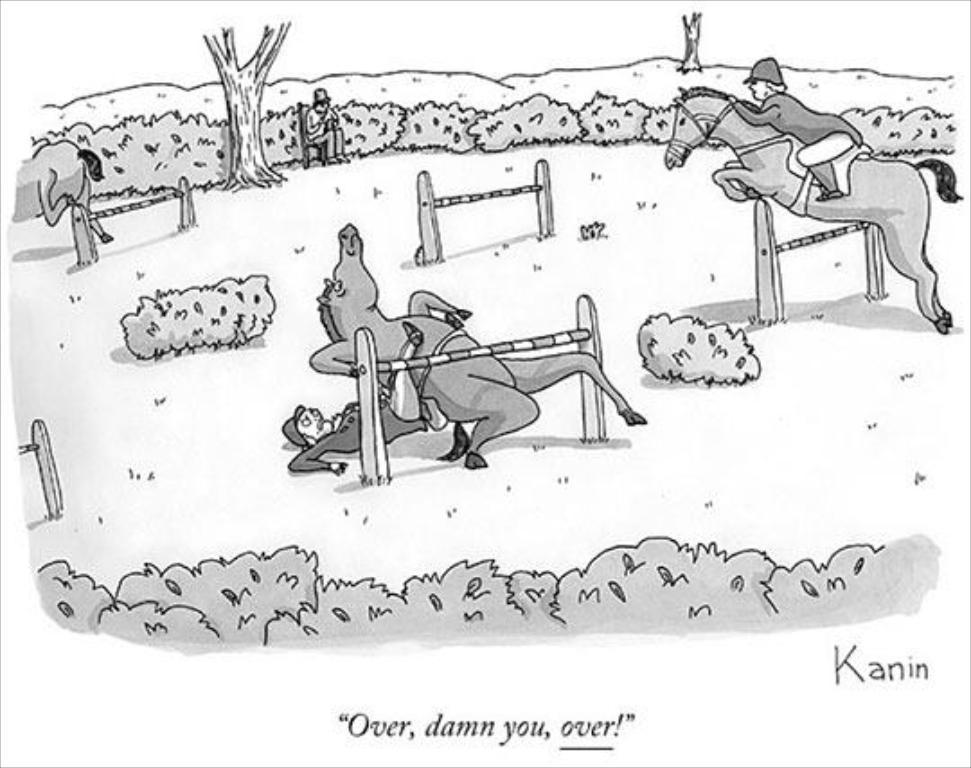What type of drawing is depicted in the image? The image is a sketch. What types of living beings are present in the image? There are animals and persons in the image. What natural elements can be seen in the image? There are trees and plants in the image. What is the surface visible in the image? There is ground visible in the image. Is there any text included in the image? Yes, there is text at the bottom of the image. What color paint is used to create the bell in the image? There is no bell present in the image, so it is not possible to determine the color of any paint used. 